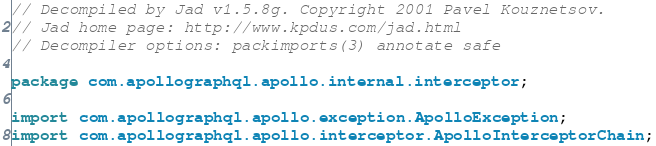<code> <loc_0><loc_0><loc_500><loc_500><_Java_>// Decompiled by Jad v1.5.8g. Copyright 2001 Pavel Kouznetsov.
// Jad home page: http://www.kpdus.com/jad.html
// Decompiler options: packimports(3) annotate safe 

package com.apollographql.apollo.internal.interceptor;

import com.apollographql.apollo.exception.ApolloException;
import com.apollographql.apollo.interceptor.ApolloInterceptorChain;</code> 